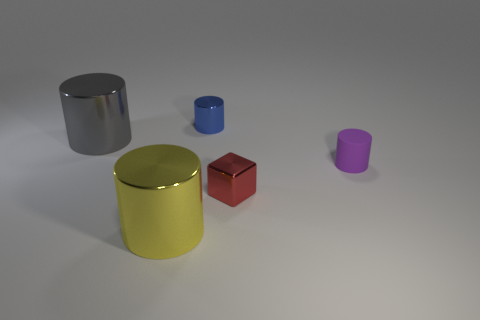Are there any other things of the same color as the small block?
Your answer should be very brief. No. There is a big metallic object that is behind the purple rubber thing; what shape is it?
Provide a short and direct response. Cylinder. There is a thing that is to the left of the tiny purple matte object and right of the tiny blue cylinder; what is its shape?
Offer a terse response. Cube. How many blue things are either big metallic cylinders or tiny shiny cylinders?
Your response must be concise. 1. There is a small cylinder that is right of the blue metal object; is its color the same as the small cube?
Your response must be concise. No. How big is the thing that is on the right side of the metallic thing that is right of the small blue cylinder?
Your answer should be compact. Small. There is a block that is the same size as the matte cylinder; what is it made of?
Offer a terse response. Metal. How many other things are the same size as the red thing?
Make the answer very short. 2. What number of balls are purple matte things or tiny red things?
Keep it short and to the point. 0. Is there anything else that has the same material as the tiny blue object?
Make the answer very short. Yes. 